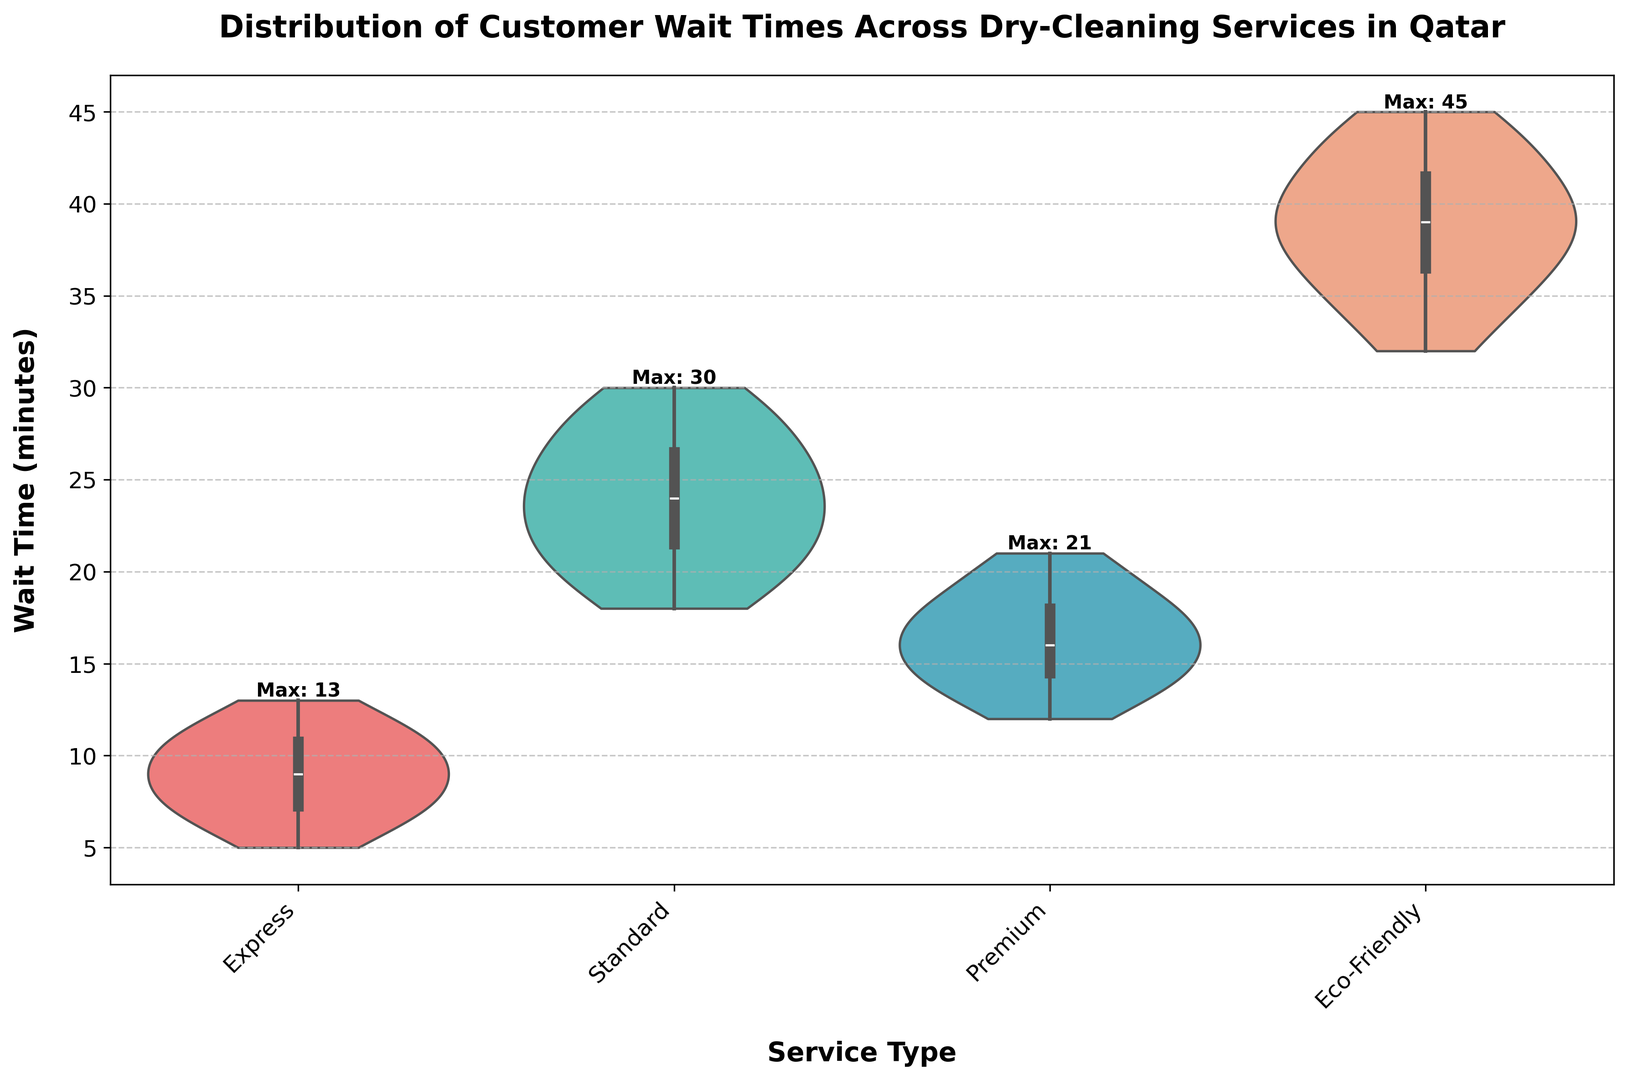Which service type has the shortest maximum wait time? The plot shows the maximum wait time indicated for each service at the top of the respective violin plots. The shortest maximum wait time is shown above the "Express" service.
Answer: Express Which service has the longest median wait time? We determine the median wait time by locating the middle line within each violin plot, and the longest median wait time appears to be in the "Eco-Friendly" service.
Answer: Eco-Friendly How does the interquartile range (IQR) of wait times for Premium service compare to that of Standard service? The IQR can be observed by looking at the width of the thicker part of the violin plots. The IQR for the "Standard" service appears larger than that of the "Premium" service, suggesting more variability in wait times for the "Standard" service.
Answer: Standard has larger IQR Which service shows the most variability in wait times? The most variability in wait times is indicated by the widest and tallest violin plot, which belongs to the "Eco-Friendly" service.
Answer: Eco-Friendly What is the difference between the maximum wait times for Standard and Premium services? The maximum wait time for "Standard" is 30 minutes and for "Premium" is 21 minutes. The difference is 30 - 21 = 9 minutes.
Answer: 9 minutes Between which two services is the median wait time closest? By comparing the central lines of all violin plots, the median wait times of "Premium" and "Express" services seem closest to each other.
Answer: Premium and Express Which service has a wait time distribution with the least skewness? Examining the shape and symmetry of the violin plots, the "Premium" service appears to have a more symmetric and balanced distribution, indicating the least skewness.
Answer: Premium Identify the service with the highest wait time and mention its value. The highest wait time value is labeled on the "Eco-Friendly" service violin plot, which is 45 minutes.
Answer: 45 minutes 